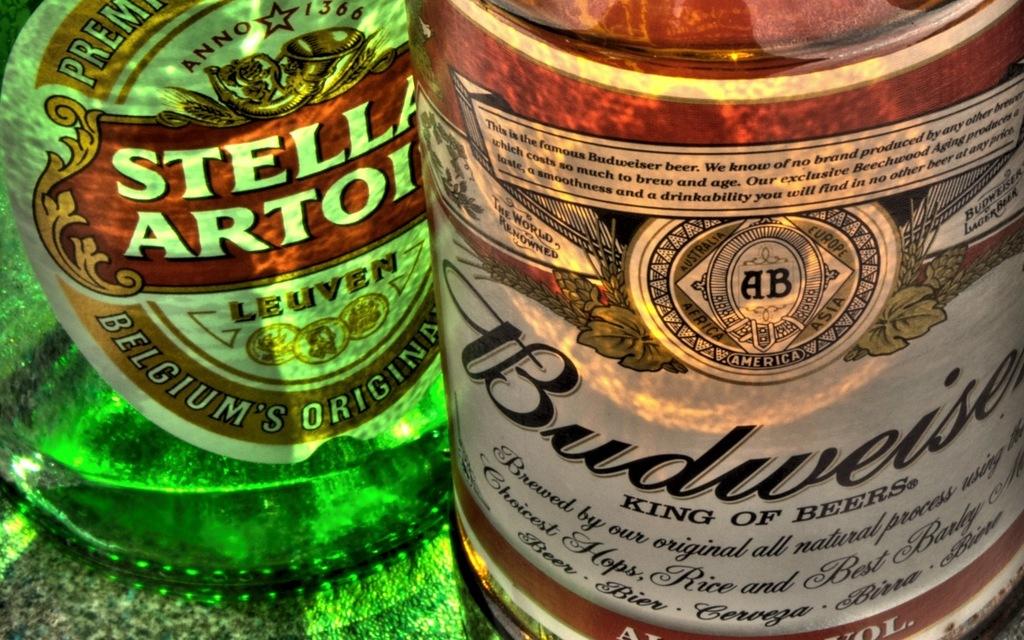What rank does the beer on the right claim compared to other beers?
Make the answer very short. King. Where is the beer on the left from?
Keep it short and to the point. Belgium. 